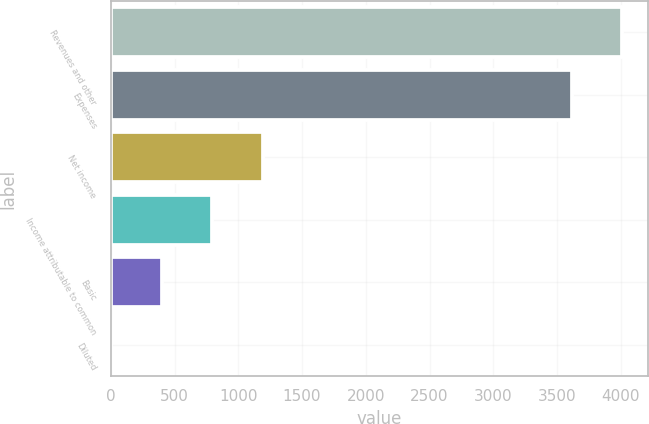Convert chart. <chart><loc_0><loc_0><loc_500><loc_500><bar_chart><fcel>Revenues and other<fcel>Expenses<fcel>Net income<fcel>Income attributable to common<fcel>Basic<fcel>Diluted<nl><fcel>4013.11<fcel>3616<fcel>1192.19<fcel>795.08<fcel>397.97<fcel>0.86<nl></chart> 